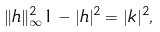<formula> <loc_0><loc_0><loc_500><loc_500>\| h \| _ { \infty } ^ { 2 } 1 - | h | ^ { 2 } = | k | ^ { 2 } ,</formula> 